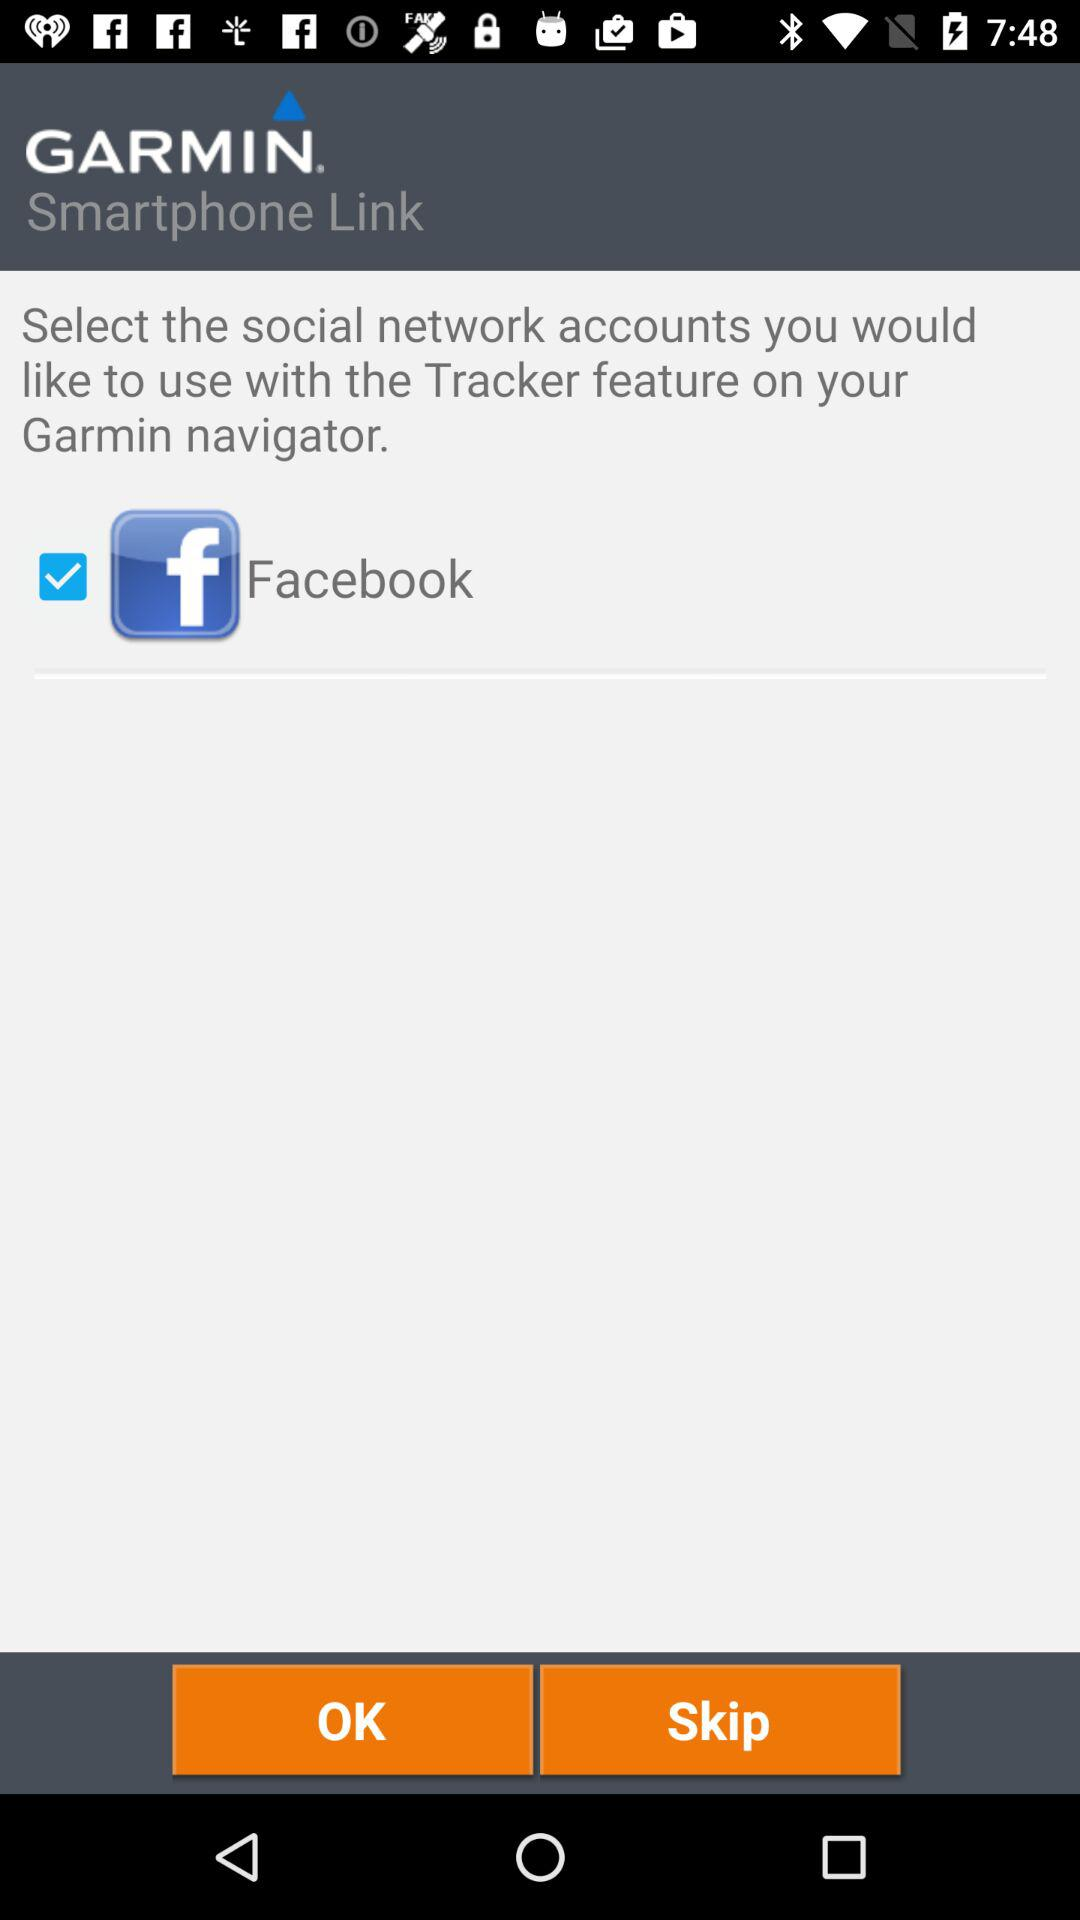What social network account is selected? The selected social network account is "Facebook". 